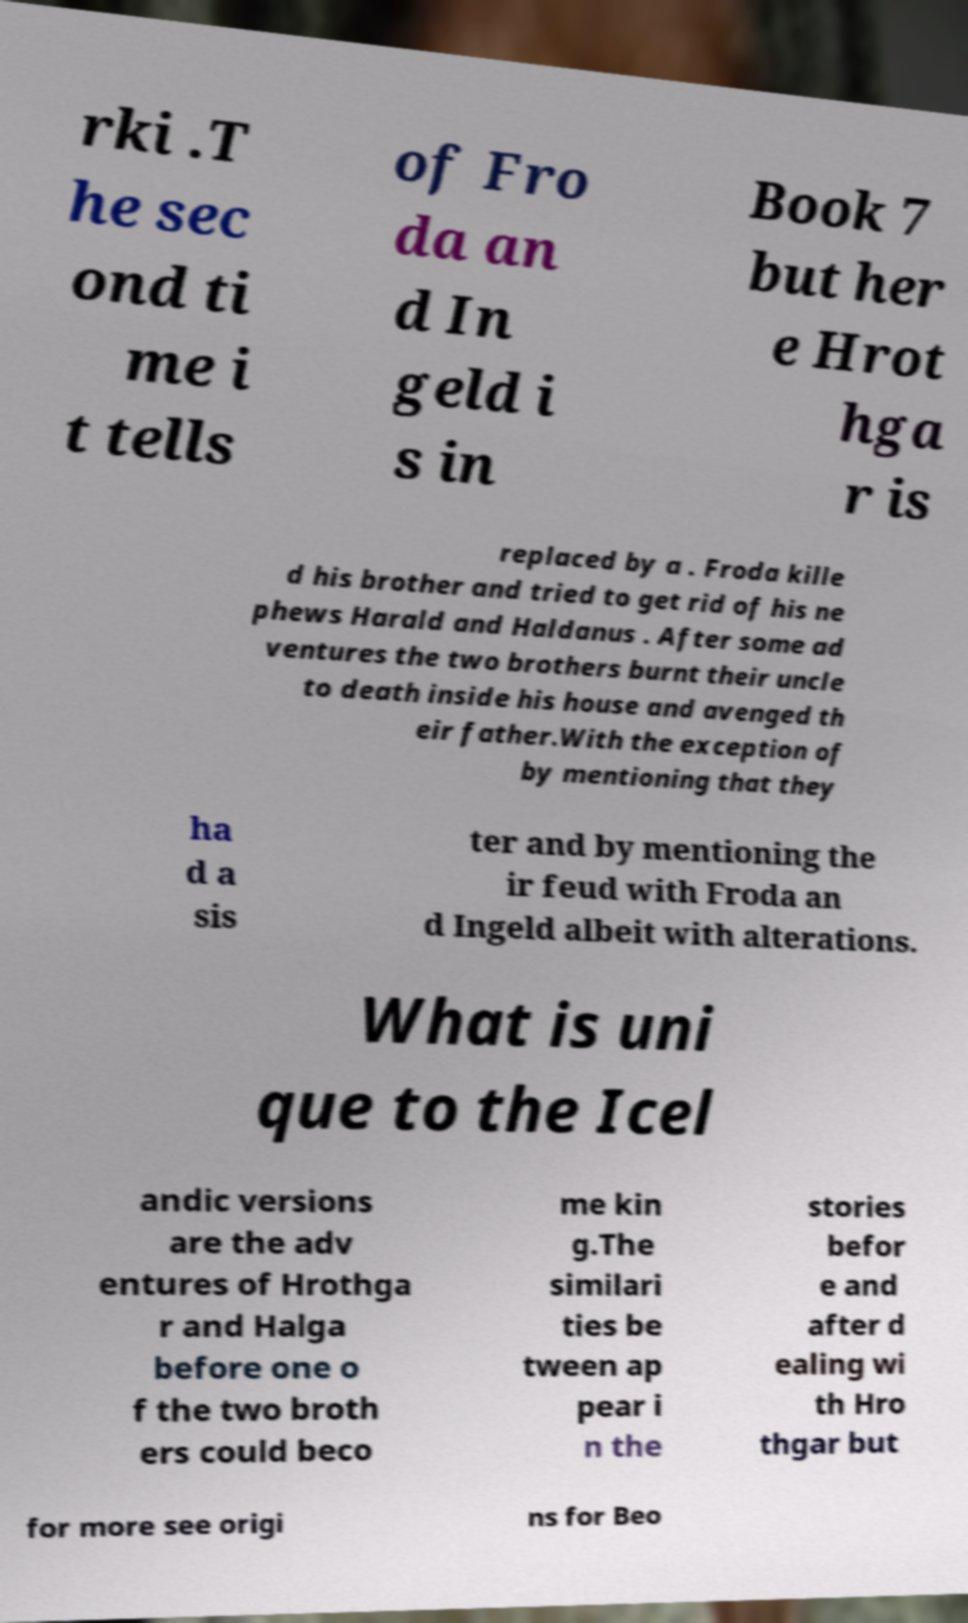Can you accurately transcribe the text from the provided image for me? rki .T he sec ond ti me i t tells of Fro da an d In geld i s in Book 7 but her e Hrot hga r is replaced by a . Froda kille d his brother and tried to get rid of his ne phews Harald and Haldanus . After some ad ventures the two brothers burnt their uncle to death inside his house and avenged th eir father.With the exception of by mentioning that they ha d a sis ter and by mentioning the ir feud with Froda an d Ingeld albeit with alterations. What is uni que to the Icel andic versions are the adv entures of Hrothga r and Halga before one o f the two broth ers could beco me kin g.The similari ties be tween ap pear i n the stories befor e and after d ealing wi th Hro thgar but for more see origi ns for Beo 